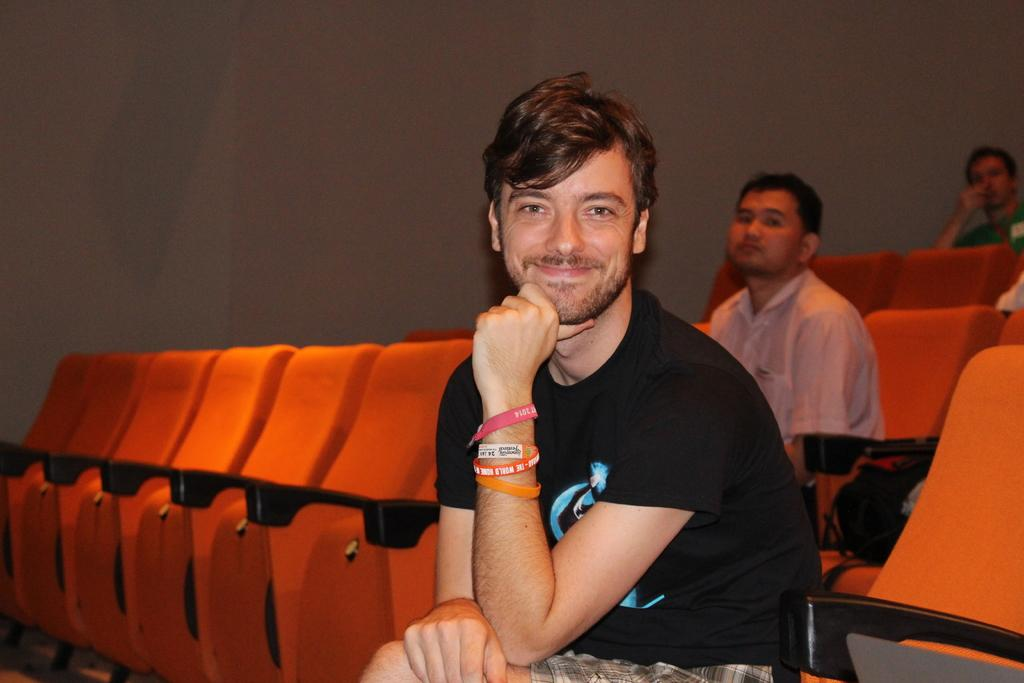What is happening in the image? There is a group of people in the image. What are the people doing in the image? The people are sitting on chairs. What can be seen in the background of the image? There is a wall visible in the background of the image. What type of soup is being served in the image? There is no soup present in the image. What is the aftermath of the event in the image? There is no event or aftermath depicted in the image; it simply shows a group of people sitting on chairs with a wall in the background. 